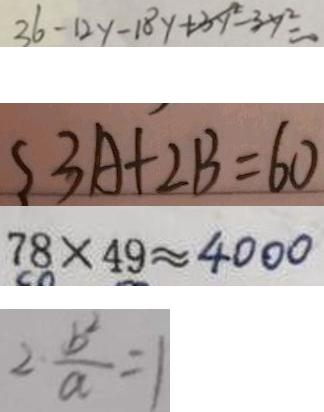Convert formula to latex. <formula><loc_0><loc_0><loc_500><loc_500>3 6 - 1 2 y - 1 8 y + 3 y ^ { 2 } - 3 y ^ { 2 } = 0 
 \{ 3 A + 2 B = 6 0 
 7 8 \times 4 9 \approx 4 0 0 0 
 2 \frac { b ^ { 2 } } { a } = 1</formula> 